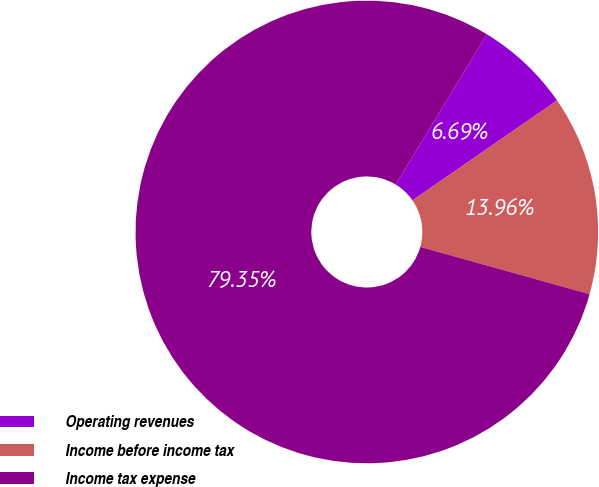Convert chart to OTSL. <chart><loc_0><loc_0><loc_500><loc_500><pie_chart><fcel>Operating revenues<fcel>Income before income tax<fcel>Income tax expense<nl><fcel>6.69%<fcel>13.96%<fcel>79.35%<nl></chart> 